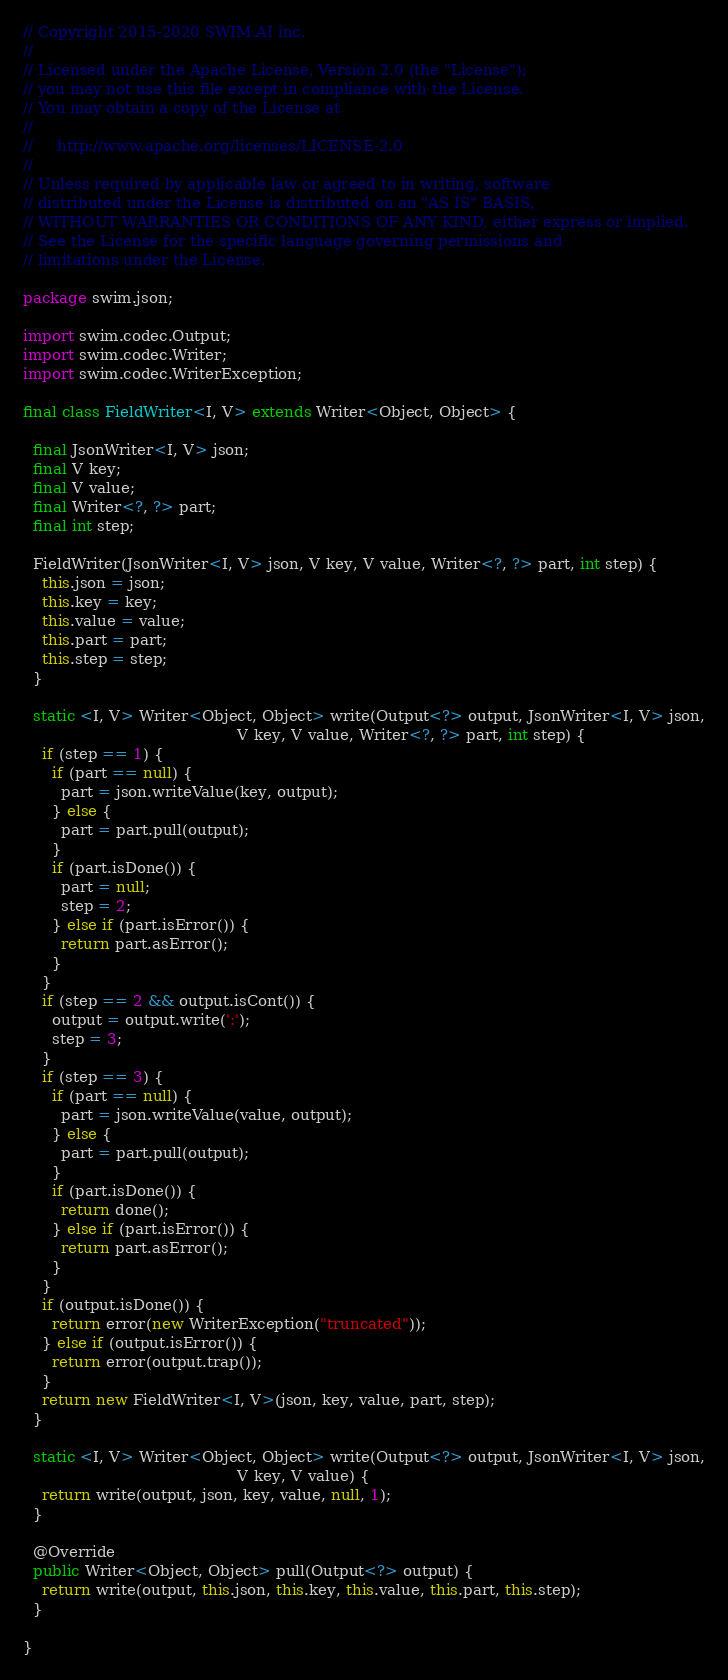<code> <loc_0><loc_0><loc_500><loc_500><_Java_>// Copyright 2015-2020 SWIM.AI inc.
//
// Licensed under the Apache License, Version 2.0 (the "License");
// you may not use this file except in compliance with the License.
// You may obtain a copy of the License at
//
//     http://www.apache.org/licenses/LICENSE-2.0
//
// Unless required by applicable law or agreed to in writing, software
// distributed under the License is distributed on an "AS IS" BASIS,
// WITHOUT WARRANTIES OR CONDITIONS OF ANY KIND, either express or implied.
// See the License for the specific language governing permissions and
// limitations under the License.

package swim.json;

import swim.codec.Output;
import swim.codec.Writer;
import swim.codec.WriterException;

final class FieldWriter<I, V> extends Writer<Object, Object> {

  final JsonWriter<I, V> json;
  final V key;
  final V value;
  final Writer<?, ?> part;
  final int step;

  FieldWriter(JsonWriter<I, V> json, V key, V value, Writer<?, ?> part, int step) {
    this.json = json;
    this.key = key;
    this.value = value;
    this.part = part;
    this.step = step;
  }

  static <I, V> Writer<Object, Object> write(Output<?> output, JsonWriter<I, V> json,
                                             V key, V value, Writer<?, ?> part, int step) {
    if (step == 1) {
      if (part == null) {
        part = json.writeValue(key, output);
      } else {
        part = part.pull(output);
      }
      if (part.isDone()) {
        part = null;
        step = 2;
      } else if (part.isError()) {
        return part.asError();
      }
    }
    if (step == 2 && output.isCont()) {
      output = output.write(':');
      step = 3;
    }
    if (step == 3) {
      if (part == null) {
        part = json.writeValue(value, output);
      } else {
        part = part.pull(output);
      }
      if (part.isDone()) {
        return done();
      } else if (part.isError()) {
        return part.asError();
      }
    }
    if (output.isDone()) {
      return error(new WriterException("truncated"));
    } else if (output.isError()) {
      return error(output.trap());
    }
    return new FieldWriter<I, V>(json, key, value, part, step);
  }

  static <I, V> Writer<Object, Object> write(Output<?> output, JsonWriter<I, V> json,
                                             V key, V value) {
    return write(output, json, key, value, null, 1);
  }

  @Override
  public Writer<Object, Object> pull(Output<?> output) {
    return write(output, this.json, this.key, this.value, this.part, this.step);
  }

}
</code> 